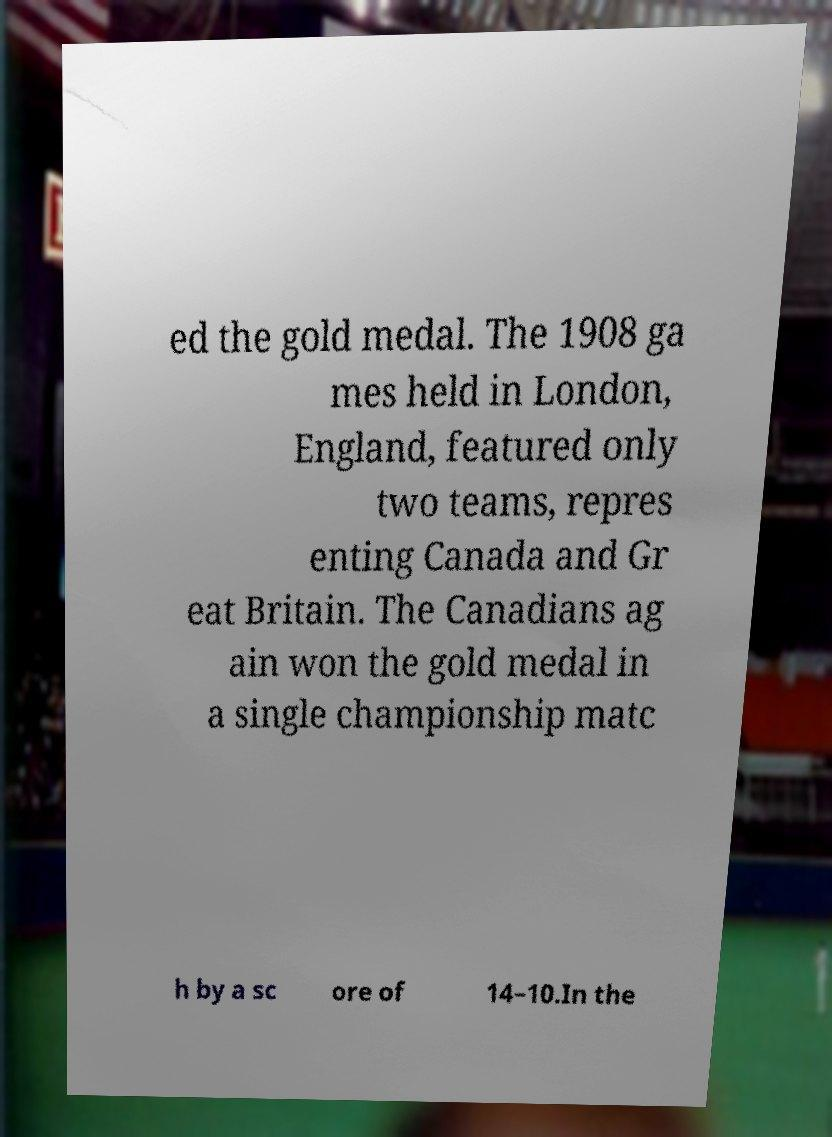Please identify and transcribe the text found in this image. ed the gold medal. The 1908 ga mes held in London, England, featured only two teams, repres enting Canada and Gr eat Britain. The Canadians ag ain won the gold medal in a single championship matc h by a sc ore of 14–10.In the 